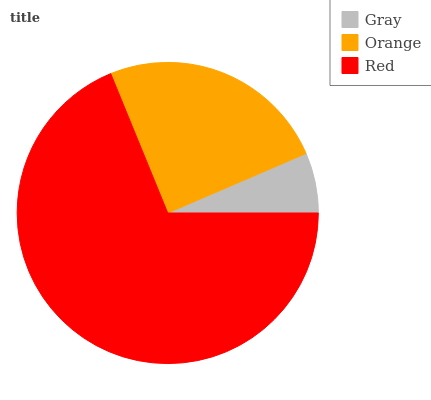Is Gray the minimum?
Answer yes or no. Yes. Is Red the maximum?
Answer yes or no. Yes. Is Orange the minimum?
Answer yes or no. No. Is Orange the maximum?
Answer yes or no. No. Is Orange greater than Gray?
Answer yes or no. Yes. Is Gray less than Orange?
Answer yes or no. Yes. Is Gray greater than Orange?
Answer yes or no. No. Is Orange less than Gray?
Answer yes or no. No. Is Orange the high median?
Answer yes or no. Yes. Is Orange the low median?
Answer yes or no. Yes. Is Gray the high median?
Answer yes or no. No. Is Red the low median?
Answer yes or no. No. 